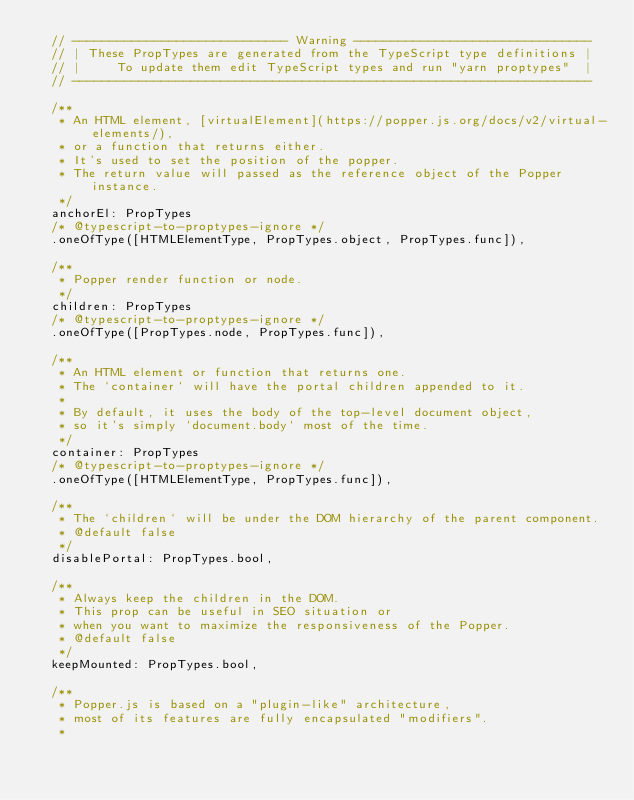<code> <loc_0><loc_0><loc_500><loc_500><_JavaScript_>  // ----------------------------- Warning --------------------------------
  // | These PropTypes are generated from the TypeScript type definitions |
  // |     To update them edit TypeScript types and run "yarn proptypes"  |
  // ----------------------------------------------------------------------

  /**
   * An HTML element, [virtualElement](https://popper.js.org/docs/v2/virtual-elements/),
   * or a function that returns either.
   * It's used to set the position of the popper.
   * The return value will passed as the reference object of the Popper instance.
   */
  anchorEl: PropTypes
  /* @typescript-to-proptypes-ignore */
  .oneOfType([HTMLElementType, PropTypes.object, PropTypes.func]),

  /**
   * Popper render function or node.
   */
  children: PropTypes
  /* @typescript-to-proptypes-ignore */
  .oneOfType([PropTypes.node, PropTypes.func]),

  /**
   * An HTML element or function that returns one.
   * The `container` will have the portal children appended to it.
   *
   * By default, it uses the body of the top-level document object,
   * so it's simply `document.body` most of the time.
   */
  container: PropTypes
  /* @typescript-to-proptypes-ignore */
  .oneOfType([HTMLElementType, PropTypes.func]),

  /**
   * The `children` will be under the DOM hierarchy of the parent component.
   * @default false
   */
  disablePortal: PropTypes.bool,

  /**
   * Always keep the children in the DOM.
   * This prop can be useful in SEO situation or
   * when you want to maximize the responsiveness of the Popper.
   * @default false
   */
  keepMounted: PropTypes.bool,

  /**
   * Popper.js is based on a "plugin-like" architecture,
   * most of its features are fully encapsulated "modifiers".
   *</code> 